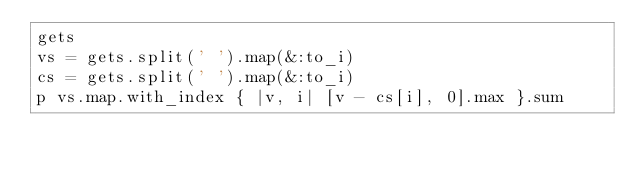Convert code to text. <code><loc_0><loc_0><loc_500><loc_500><_Ruby_>gets
vs = gets.split(' ').map(&:to_i)
cs = gets.split(' ').map(&:to_i)
p vs.map.with_index { |v, i| [v - cs[i], 0].max }.sum</code> 